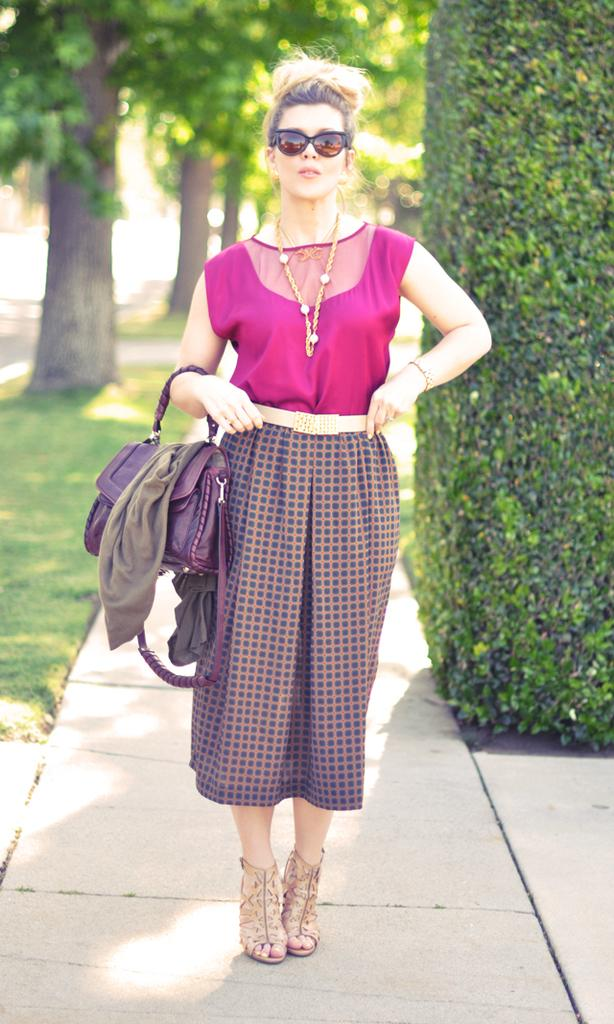Who is present in the image? There is a woman in the image. What is the woman standing on? The woman is standing on a walkway. What accessories is the woman wearing? The woman is wearing a bag and goggles. What can be seen in the background of the image? There is grass, plants, and trees in the background of the image. How many dust particles can be seen on the woman's goggles in the image? There is no information about dust particles on the woman's goggles in the image, so it cannot be determined. What type of dolls are present in the image? There are no dolls present in the image. 